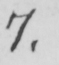Please transcribe the handwritten text in this image. 7 . 